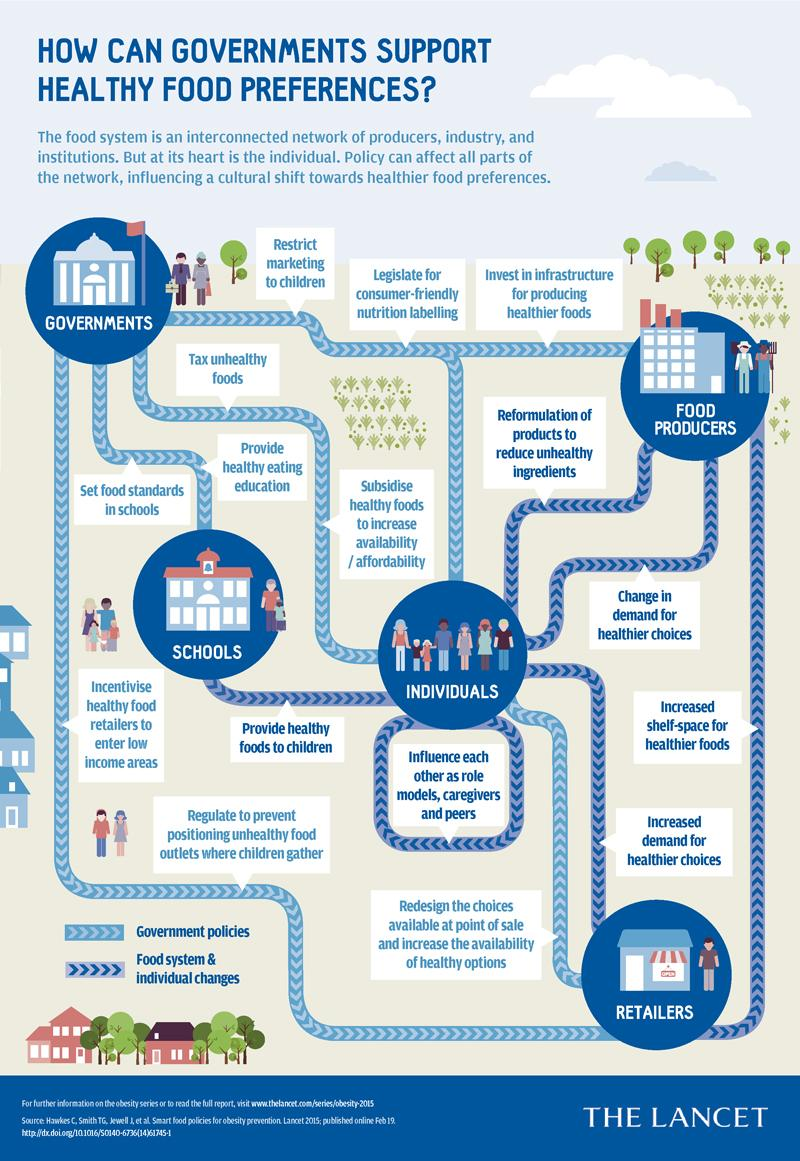List a handful of essential elements in this visual. The government has the authority to impose taxes on unhealthy foods. In order to improve access to healthy food for the general public, the government shall subsidize healthy food options. Each individual has the potential to influence others as role models, caregivers, and peers, and can benefit from being influenced in return. Retailers can promote healthy eating by increasing the shelf-space dedicated to healthier food options, which will make it easier for consumers to choose nutritious foods. Increased demand for healthier choices by individuals can influence retailers to promote healthy eating. 